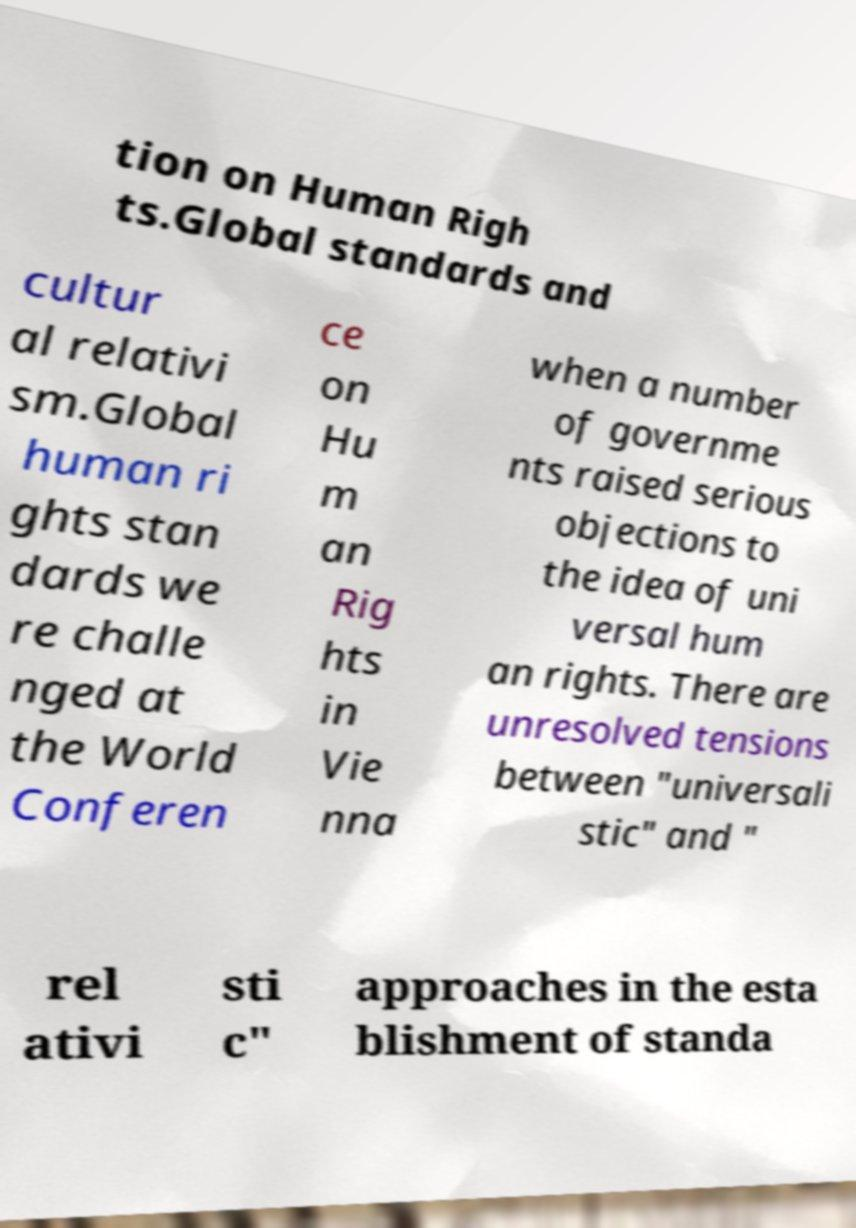Could you assist in decoding the text presented in this image and type it out clearly? tion on Human Righ ts.Global standards and cultur al relativi sm.Global human ri ghts stan dards we re challe nged at the World Conferen ce on Hu m an Rig hts in Vie nna when a number of governme nts raised serious objections to the idea of uni versal hum an rights. There are unresolved tensions between "universali stic" and " rel ativi sti c" approaches in the esta blishment of standa 